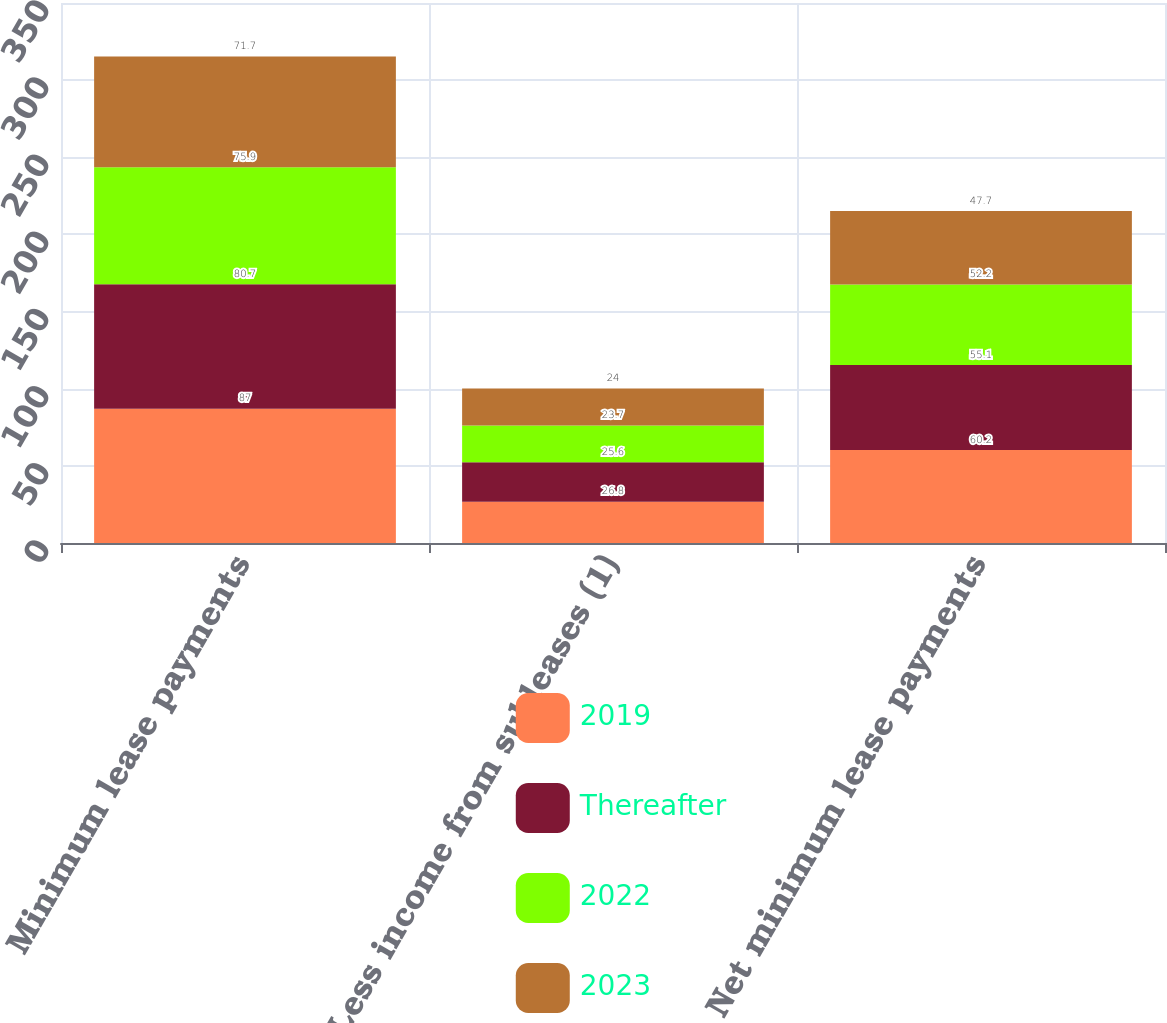Convert chart to OTSL. <chart><loc_0><loc_0><loc_500><loc_500><stacked_bar_chart><ecel><fcel>Minimum lease payments<fcel>Less income from subleases (1)<fcel>Net minimum lease payments<nl><fcel>2019<fcel>87<fcel>26.8<fcel>60.2<nl><fcel>Thereafter<fcel>80.7<fcel>25.6<fcel>55.1<nl><fcel>2022<fcel>75.9<fcel>23.7<fcel>52.2<nl><fcel>2023<fcel>71.7<fcel>24<fcel>47.7<nl></chart> 